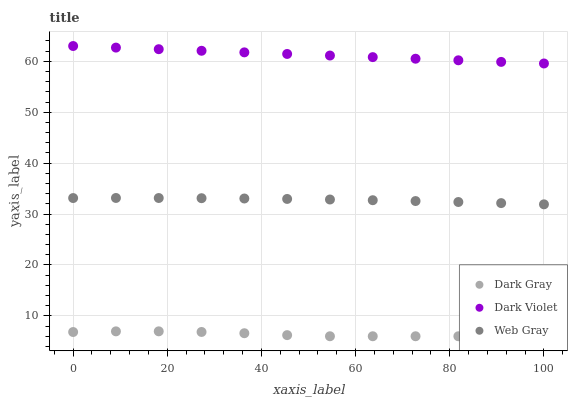Does Dark Gray have the minimum area under the curve?
Answer yes or no. Yes. Does Dark Violet have the maximum area under the curve?
Answer yes or no. Yes. Does Web Gray have the minimum area under the curve?
Answer yes or no. No. Does Web Gray have the maximum area under the curve?
Answer yes or no. No. Is Dark Violet the smoothest?
Answer yes or no. Yes. Is Dark Gray the roughest?
Answer yes or no. Yes. Is Web Gray the smoothest?
Answer yes or no. No. Is Web Gray the roughest?
Answer yes or no. No. Does Dark Gray have the lowest value?
Answer yes or no. Yes. Does Web Gray have the lowest value?
Answer yes or no. No. Does Dark Violet have the highest value?
Answer yes or no. Yes. Does Web Gray have the highest value?
Answer yes or no. No. Is Dark Gray less than Dark Violet?
Answer yes or no. Yes. Is Web Gray greater than Dark Gray?
Answer yes or no. Yes. Does Dark Gray intersect Dark Violet?
Answer yes or no. No. 